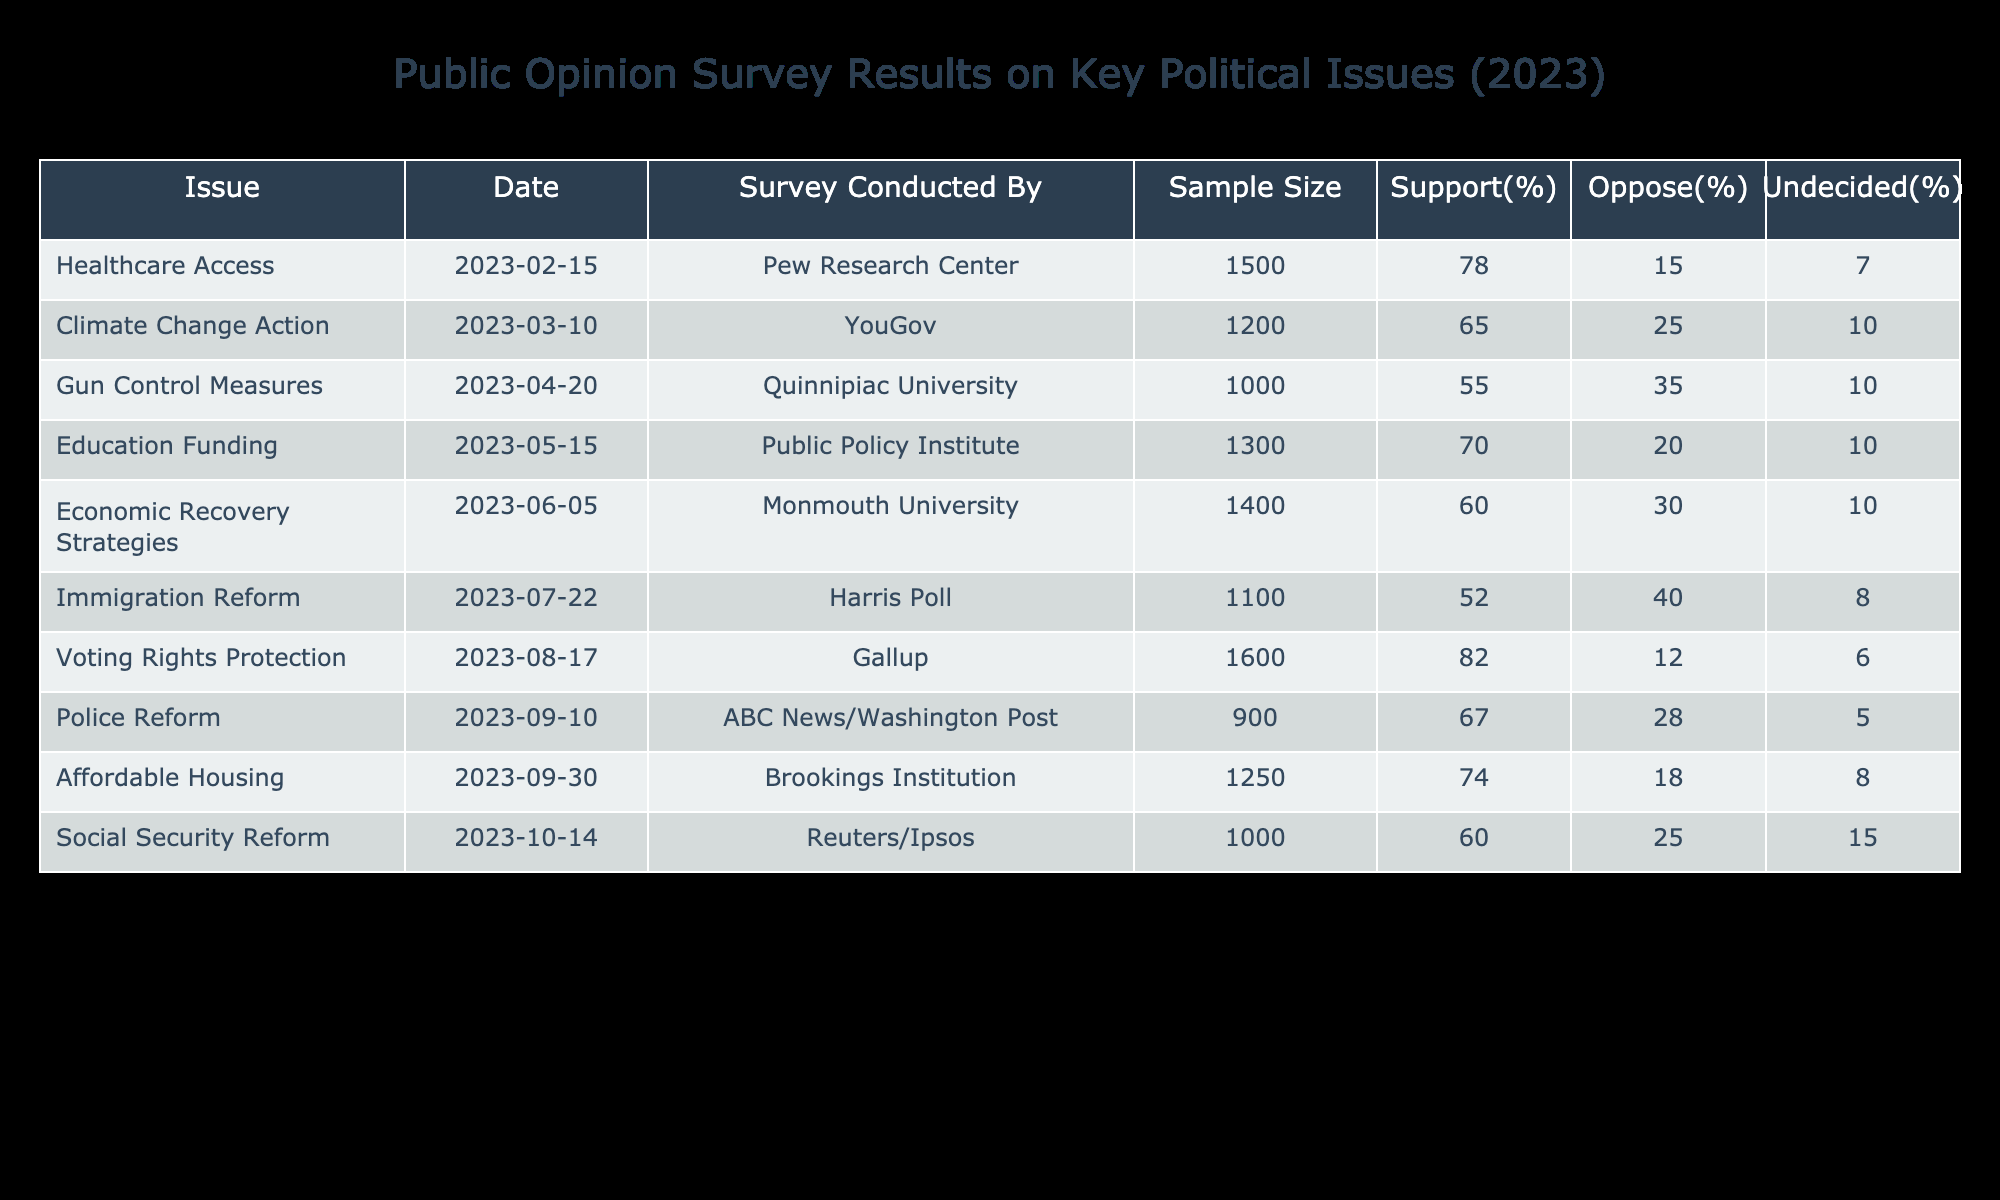What percentage of people supported Healthcare Access? The table indicates that 78% of the respondents supported Healthcare Access as the value is directly given in the "Support(%)" column under the "Healthcare Access" row.
Answer: 78% Which issue had the highest opposition percentage? By examining the "Oppose(%)" column across all issues, Immigration Reform had the highest opposition percentage at 40%.
Answer: 40% What is the average support percentage for issues related to economic concerns (Economic Recovery Strategies and Affordable Housing)? First, sum the support percentages for Economic Recovery Strategies (60%) and Affordable Housing (74%), which gives 134%. Then, divide this total by the number of issues, which is 2. Therefore, the average support is 134% / 2 = 67%.
Answer: 67% Is there more support for Voting Rights Protection compared to Gun Control Measures? The support percentage for Voting Rights Protection is 82%, while the support for Gun Control Measures is 55%. Since 82% is greater than 55%, there is indeed more support for Voting Rights Protection.
Answer: Yes How much higher is the support for Education Funding compared to Gun Control Measures? The support for Education Funding is 70%, and for Gun Control Measures, it is 55%. Subtract the latter from the former: 70% - 55% = 15%. Therefore, support for Education Funding is 15% higher than for Gun Control Measures.
Answer: 15% 